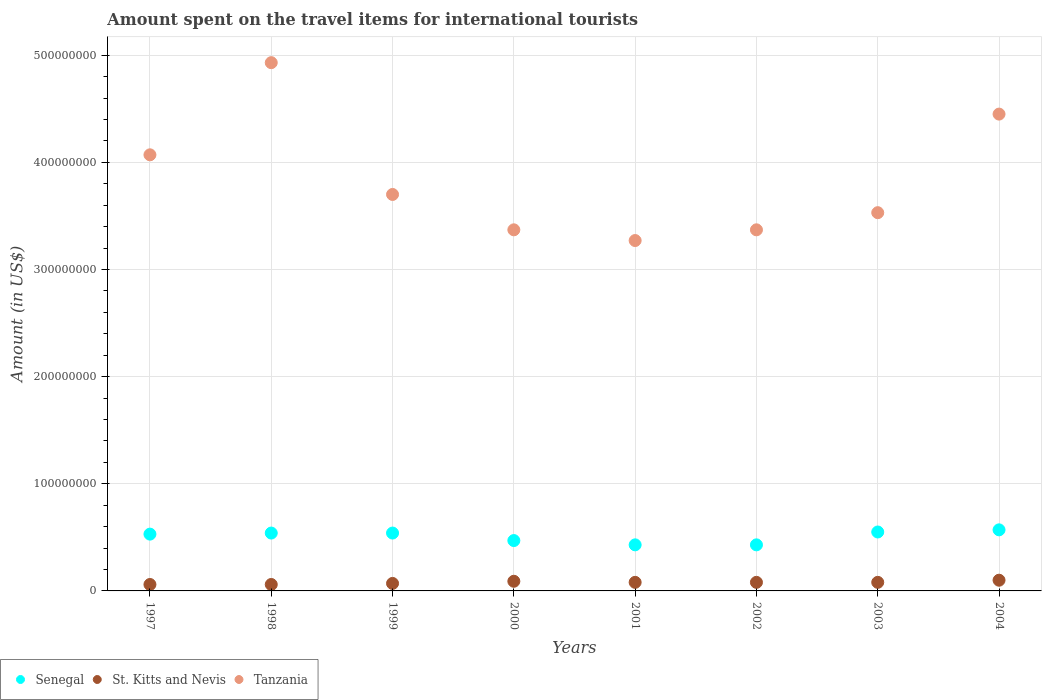How many different coloured dotlines are there?
Provide a succinct answer. 3. Is the number of dotlines equal to the number of legend labels?
Give a very brief answer. Yes. What is the amount spent on the travel items for international tourists in St. Kitts and Nevis in 2000?
Offer a very short reply. 9.00e+06. Across all years, what is the maximum amount spent on the travel items for international tourists in Tanzania?
Ensure brevity in your answer.  4.93e+08. Across all years, what is the minimum amount spent on the travel items for international tourists in Senegal?
Provide a succinct answer. 4.30e+07. What is the total amount spent on the travel items for international tourists in St. Kitts and Nevis in the graph?
Provide a short and direct response. 6.20e+07. What is the difference between the amount spent on the travel items for international tourists in St. Kitts and Nevis in 1997 and that in 2000?
Your answer should be compact. -3.00e+06. What is the difference between the amount spent on the travel items for international tourists in Tanzania in 2004 and the amount spent on the travel items for international tourists in St. Kitts and Nevis in 2003?
Offer a terse response. 4.37e+08. What is the average amount spent on the travel items for international tourists in St. Kitts and Nevis per year?
Your response must be concise. 7.75e+06. In the year 2003, what is the difference between the amount spent on the travel items for international tourists in Senegal and amount spent on the travel items for international tourists in Tanzania?
Provide a succinct answer. -2.98e+08. What is the ratio of the amount spent on the travel items for international tourists in St. Kitts and Nevis in 1997 to that in 2002?
Your answer should be compact. 0.75. Is the amount spent on the travel items for international tourists in St. Kitts and Nevis in 2001 less than that in 2002?
Ensure brevity in your answer.  No. What is the difference between the highest and the second highest amount spent on the travel items for international tourists in Tanzania?
Your answer should be compact. 4.80e+07. What is the difference between the highest and the lowest amount spent on the travel items for international tourists in St. Kitts and Nevis?
Your answer should be very brief. 4.00e+06. Is it the case that in every year, the sum of the amount spent on the travel items for international tourists in St. Kitts and Nevis and amount spent on the travel items for international tourists in Senegal  is greater than the amount spent on the travel items for international tourists in Tanzania?
Your answer should be compact. No. Does the amount spent on the travel items for international tourists in Senegal monotonically increase over the years?
Your answer should be compact. No. Is the amount spent on the travel items for international tourists in Senegal strictly greater than the amount spent on the travel items for international tourists in Tanzania over the years?
Ensure brevity in your answer.  No. Is the amount spent on the travel items for international tourists in Senegal strictly less than the amount spent on the travel items for international tourists in St. Kitts and Nevis over the years?
Provide a succinct answer. No. How many dotlines are there?
Offer a very short reply. 3. How many years are there in the graph?
Offer a terse response. 8. Where does the legend appear in the graph?
Ensure brevity in your answer.  Bottom left. How many legend labels are there?
Offer a terse response. 3. What is the title of the graph?
Make the answer very short. Amount spent on the travel items for international tourists. What is the label or title of the X-axis?
Provide a succinct answer. Years. What is the label or title of the Y-axis?
Make the answer very short. Amount (in US$). What is the Amount (in US$) in Senegal in 1997?
Offer a terse response. 5.30e+07. What is the Amount (in US$) in St. Kitts and Nevis in 1997?
Offer a terse response. 6.00e+06. What is the Amount (in US$) in Tanzania in 1997?
Offer a very short reply. 4.07e+08. What is the Amount (in US$) of Senegal in 1998?
Your answer should be very brief. 5.40e+07. What is the Amount (in US$) of Tanzania in 1998?
Ensure brevity in your answer.  4.93e+08. What is the Amount (in US$) of Senegal in 1999?
Offer a very short reply. 5.40e+07. What is the Amount (in US$) of St. Kitts and Nevis in 1999?
Your answer should be very brief. 7.00e+06. What is the Amount (in US$) of Tanzania in 1999?
Your response must be concise. 3.70e+08. What is the Amount (in US$) in Senegal in 2000?
Your answer should be very brief. 4.70e+07. What is the Amount (in US$) of St. Kitts and Nevis in 2000?
Keep it short and to the point. 9.00e+06. What is the Amount (in US$) in Tanzania in 2000?
Ensure brevity in your answer.  3.37e+08. What is the Amount (in US$) in Senegal in 2001?
Provide a short and direct response. 4.30e+07. What is the Amount (in US$) in St. Kitts and Nevis in 2001?
Ensure brevity in your answer.  8.00e+06. What is the Amount (in US$) of Tanzania in 2001?
Offer a very short reply. 3.27e+08. What is the Amount (in US$) of Senegal in 2002?
Offer a terse response. 4.30e+07. What is the Amount (in US$) in St. Kitts and Nevis in 2002?
Offer a very short reply. 8.00e+06. What is the Amount (in US$) in Tanzania in 2002?
Make the answer very short. 3.37e+08. What is the Amount (in US$) of Senegal in 2003?
Ensure brevity in your answer.  5.50e+07. What is the Amount (in US$) in St. Kitts and Nevis in 2003?
Your answer should be very brief. 8.00e+06. What is the Amount (in US$) in Tanzania in 2003?
Provide a succinct answer. 3.53e+08. What is the Amount (in US$) of Senegal in 2004?
Make the answer very short. 5.70e+07. What is the Amount (in US$) in Tanzania in 2004?
Provide a short and direct response. 4.45e+08. Across all years, what is the maximum Amount (in US$) in Senegal?
Keep it short and to the point. 5.70e+07. Across all years, what is the maximum Amount (in US$) of Tanzania?
Your answer should be compact. 4.93e+08. Across all years, what is the minimum Amount (in US$) of Senegal?
Keep it short and to the point. 4.30e+07. Across all years, what is the minimum Amount (in US$) of Tanzania?
Keep it short and to the point. 3.27e+08. What is the total Amount (in US$) in Senegal in the graph?
Your answer should be compact. 4.06e+08. What is the total Amount (in US$) in St. Kitts and Nevis in the graph?
Provide a succinct answer. 6.20e+07. What is the total Amount (in US$) of Tanzania in the graph?
Ensure brevity in your answer.  3.07e+09. What is the difference between the Amount (in US$) in Senegal in 1997 and that in 1998?
Your answer should be compact. -1.00e+06. What is the difference between the Amount (in US$) in St. Kitts and Nevis in 1997 and that in 1998?
Provide a short and direct response. 0. What is the difference between the Amount (in US$) of Tanzania in 1997 and that in 1998?
Your response must be concise. -8.60e+07. What is the difference between the Amount (in US$) in St. Kitts and Nevis in 1997 and that in 1999?
Ensure brevity in your answer.  -1.00e+06. What is the difference between the Amount (in US$) in Tanzania in 1997 and that in 1999?
Give a very brief answer. 3.70e+07. What is the difference between the Amount (in US$) in Senegal in 1997 and that in 2000?
Provide a succinct answer. 6.00e+06. What is the difference between the Amount (in US$) in Tanzania in 1997 and that in 2000?
Your response must be concise. 7.00e+07. What is the difference between the Amount (in US$) of Tanzania in 1997 and that in 2001?
Offer a very short reply. 8.00e+07. What is the difference between the Amount (in US$) in Tanzania in 1997 and that in 2002?
Offer a terse response. 7.00e+07. What is the difference between the Amount (in US$) of Senegal in 1997 and that in 2003?
Give a very brief answer. -2.00e+06. What is the difference between the Amount (in US$) of Tanzania in 1997 and that in 2003?
Your answer should be compact. 5.40e+07. What is the difference between the Amount (in US$) in St. Kitts and Nevis in 1997 and that in 2004?
Provide a short and direct response. -4.00e+06. What is the difference between the Amount (in US$) in Tanzania in 1997 and that in 2004?
Provide a succinct answer. -3.80e+07. What is the difference between the Amount (in US$) in Senegal in 1998 and that in 1999?
Keep it short and to the point. 0. What is the difference between the Amount (in US$) in Tanzania in 1998 and that in 1999?
Give a very brief answer. 1.23e+08. What is the difference between the Amount (in US$) in St. Kitts and Nevis in 1998 and that in 2000?
Your response must be concise. -3.00e+06. What is the difference between the Amount (in US$) in Tanzania in 1998 and that in 2000?
Your answer should be compact. 1.56e+08. What is the difference between the Amount (in US$) in Senegal in 1998 and that in 2001?
Provide a short and direct response. 1.10e+07. What is the difference between the Amount (in US$) in Tanzania in 1998 and that in 2001?
Keep it short and to the point. 1.66e+08. What is the difference between the Amount (in US$) in Senegal in 1998 and that in 2002?
Your answer should be compact. 1.10e+07. What is the difference between the Amount (in US$) of Tanzania in 1998 and that in 2002?
Your answer should be compact. 1.56e+08. What is the difference between the Amount (in US$) of Senegal in 1998 and that in 2003?
Make the answer very short. -1.00e+06. What is the difference between the Amount (in US$) of St. Kitts and Nevis in 1998 and that in 2003?
Your response must be concise. -2.00e+06. What is the difference between the Amount (in US$) in Tanzania in 1998 and that in 2003?
Your answer should be very brief. 1.40e+08. What is the difference between the Amount (in US$) in Senegal in 1998 and that in 2004?
Ensure brevity in your answer.  -3.00e+06. What is the difference between the Amount (in US$) in Tanzania in 1998 and that in 2004?
Offer a terse response. 4.80e+07. What is the difference between the Amount (in US$) in Senegal in 1999 and that in 2000?
Your response must be concise. 7.00e+06. What is the difference between the Amount (in US$) of St. Kitts and Nevis in 1999 and that in 2000?
Keep it short and to the point. -2.00e+06. What is the difference between the Amount (in US$) of Tanzania in 1999 and that in 2000?
Ensure brevity in your answer.  3.30e+07. What is the difference between the Amount (in US$) in Senegal in 1999 and that in 2001?
Ensure brevity in your answer.  1.10e+07. What is the difference between the Amount (in US$) in Tanzania in 1999 and that in 2001?
Keep it short and to the point. 4.30e+07. What is the difference between the Amount (in US$) of Senegal in 1999 and that in 2002?
Your response must be concise. 1.10e+07. What is the difference between the Amount (in US$) in Tanzania in 1999 and that in 2002?
Make the answer very short. 3.30e+07. What is the difference between the Amount (in US$) in St. Kitts and Nevis in 1999 and that in 2003?
Provide a short and direct response. -1.00e+06. What is the difference between the Amount (in US$) of Tanzania in 1999 and that in 2003?
Your answer should be very brief. 1.70e+07. What is the difference between the Amount (in US$) in Senegal in 1999 and that in 2004?
Your response must be concise. -3.00e+06. What is the difference between the Amount (in US$) in St. Kitts and Nevis in 1999 and that in 2004?
Make the answer very short. -3.00e+06. What is the difference between the Amount (in US$) in Tanzania in 1999 and that in 2004?
Offer a very short reply. -7.50e+07. What is the difference between the Amount (in US$) of Senegal in 2000 and that in 2001?
Keep it short and to the point. 4.00e+06. What is the difference between the Amount (in US$) of Tanzania in 2000 and that in 2001?
Keep it short and to the point. 1.00e+07. What is the difference between the Amount (in US$) of Senegal in 2000 and that in 2003?
Offer a terse response. -8.00e+06. What is the difference between the Amount (in US$) in Tanzania in 2000 and that in 2003?
Keep it short and to the point. -1.60e+07. What is the difference between the Amount (in US$) of Senegal in 2000 and that in 2004?
Offer a terse response. -1.00e+07. What is the difference between the Amount (in US$) of Tanzania in 2000 and that in 2004?
Your response must be concise. -1.08e+08. What is the difference between the Amount (in US$) of Senegal in 2001 and that in 2002?
Keep it short and to the point. 0. What is the difference between the Amount (in US$) of Tanzania in 2001 and that in 2002?
Provide a succinct answer. -1.00e+07. What is the difference between the Amount (in US$) in Senegal in 2001 and that in 2003?
Offer a very short reply. -1.20e+07. What is the difference between the Amount (in US$) of Tanzania in 2001 and that in 2003?
Offer a terse response. -2.60e+07. What is the difference between the Amount (in US$) of Senegal in 2001 and that in 2004?
Offer a terse response. -1.40e+07. What is the difference between the Amount (in US$) of St. Kitts and Nevis in 2001 and that in 2004?
Offer a terse response. -2.00e+06. What is the difference between the Amount (in US$) in Tanzania in 2001 and that in 2004?
Your response must be concise. -1.18e+08. What is the difference between the Amount (in US$) of Senegal in 2002 and that in 2003?
Offer a terse response. -1.20e+07. What is the difference between the Amount (in US$) in Tanzania in 2002 and that in 2003?
Offer a terse response. -1.60e+07. What is the difference between the Amount (in US$) in Senegal in 2002 and that in 2004?
Your answer should be very brief. -1.40e+07. What is the difference between the Amount (in US$) of St. Kitts and Nevis in 2002 and that in 2004?
Provide a succinct answer. -2.00e+06. What is the difference between the Amount (in US$) in Tanzania in 2002 and that in 2004?
Ensure brevity in your answer.  -1.08e+08. What is the difference between the Amount (in US$) in Senegal in 2003 and that in 2004?
Your answer should be very brief. -2.00e+06. What is the difference between the Amount (in US$) in Tanzania in 2003 and that in 2004?
Your answer should be compact. -9.20e+07. What is the difference between the Amount (in US$) in Senegal in 1997 and the Amount (in US$) in St. Kitts and Nevis in 1998?
Provide a succinct answer. 4.70e+07. What is the difference between the Amount (in US$) of Senegal in 1997 and the Amount (in US$) of Tanzania in 1998?
Give a very brief answer. -4.40e+08. What is the difference between the Amount (in US$) in St. Kitts and Nevis in 1997 and the Amount (in US$) in Tanzania in 1998?
Provide a succinct answer. -4.87e+08. What is the difference between the Amount (in US$) of Senegal in 1997 and the Amount (in US$) of St. Kitts and Nevis in 1999?
Your response must be concise. 4.60e+07. What is the difference between the Amount (in US$) in Senegal in 1997 and the Amount (in US$) in Tanzania in 1999?
Make the answer very short. -3.17e+08. What is the difference between the Amount (in US$) in St. Kitts and Nevis in 1997 and the Amount (in US$) in Tanzania in 1999?
Your response must be concise. -3.64e+08. What is the difference between the Amount (in US$) of Senegal in 1997 and the Amount (in US$) of St. Kitts and Nevis in 2000?
Ensure brevity in your answer.  4.40e+07. What is the difference between the Amount (in US$) of Senegal in 1997 and the Amount (in US$) of Tanzania in 2000?
Your answer should be very brief. -2.84e+08. What is the difference between the Amount (in US$) in St. Kitts and Nevis in 1997 and the Amount (in US$) in Tanzania in 2000?
Give a very brief answer. -3.31e+08. What is the difference between the Amount (in US$) in Senegal in 1997 and the Amount (in US$) in St. Kitts and Nevis in 2001?
Give a very brief answer. 4.50e+07. What is the difference between the Amount (in US$) in Senegal in 1997 and the Amount (in US$) in Tanzania in 2001?
Ensure brevity in your answer.  -2.74e+08. What is the difference between the Amount (in US$) in St. Kitts and Nevis in 1997 and the Amount (in US$) in Tanzania in 2001?
Ensure brevity in your answer.  -3.21e+08. What is the difference between the Amount (in US$) in Senegal in 1997 and the Amount (in US$) in St. Kitts and Nevis in 2002?
Make the answer very short. 4.50e+07. What is the difference between the Amount (in US$) of Senegal in 1997 and the Amount (in US$) of Tanzania in 2002?
Give a very brief answer. -2.84e+08. What is the difference between the Amount (in US$) in St. Kitts and Nevis in 1997 and the Amount (in US$) in Tanzania in 2002?
Your answer should be compact. -3.31e+08. What is the difference between the Amount (in US$) of Senegal in 1997 and the Amount (in US$) of St. Kitts and Nevis in 2003?
Your answer should be very brief. 4.50e+07. What is the difference between the Amount (in US$) of Senegal in 1997 and the Amount (in US$) of Tanzania in 2003?
Your answer should be compact. -3.00e+08. What is the difference between the Amount (in US$) of St. Kitts and Nevis in 1997 and the Amount (in US$) of Tanzania in 2003?
Offer a terse response. -3.47e+08. What is the difference between the Amount (in US$) in Senegal in 1997 and the Amount (in US$) in St. Kitts and Nevis in 2004?
Provide a succinct answer. 4.30e+07. What is the difference between the Amount (in US$) in Senegal in 1997 and the Amount (in US$) in Tanzania in 2004?
Keep it short and to the point. -3.92e+08. What is the difference between the Amount (in US$) in St. Kitts and Nevis in 1997 and the Amount (in US$) in Tanzania in 2004?
Give a very brief answer. -4.39e+08. What is the difference between the Amount (in US$) in Senegal in 1998 and the Amount (in US$) in St. Kitts and Nevis in 1999?
Give a very brief answer. 4.70e+07. What is the difference between the Amount (in US$) in Senegal in 1998 and the Amount (in US$) in Tanzania in 1999?
Your answer should be compact. -3.16e+08. What is the difference between the Amount (in US$) of St. Kitts and Nevis in 1998 and the Amount (in US$) of Tanzania in 1999?
Provide a short and direct response. -3.64e+08. What is the difference between the Amount (in US$) of Senegal in 1998 and the Amount (in US$) of St. Kitts and Nevis in 2000?
Provide a short and direct response. 4.50e+07. What is the difference between the Amount (in US$) in Senegal in 1998 and the Amount (in US$) in Tanzania in 2000?
Offer a terse response. -2.83e+08. What is the difference between the Amount (in US$) in St. Kitts and Nevis in 1998 and the Amount (in US$) in Tanzania in 2000?
Provide a short and direct response. -3.31e+08. What is the difference between the Amount (in US$) of Senegal in 1998 and the Amount (in US$) of St. Kitts and Nevis in 2001?
Offer a terse response. 4.60e+07. What is the difference between the Amount (in US$) in Senegal in 1998 and the Amount (in US$) in Tanzania in 2001?
Make the answer very short. -2.73e+08. What is the difference between the Amount (in US$) of St. Kitts and Nevis in 1998 and the Amount (in US$) of Tanzania in 2001?
Offer a very short reply. -3.21e+08. What is the difference between the Amount (in US$) of Senegal in 1998 and the Amount (in US$) of St. Kitts and Nevis in 2002?
Make the answer very short. 4.60e+07. What is the difference between the Amount (in US$) of Senegal in 1998 and the Amount (in US$) of Tanzania in 2002?
Offer a terse response. -2.83e+08. What is the difference between the Amount (in US$) in St. Kitts and Nevis in 1998 and the Amount (in US$) in Tanzania in 2002?
Your response must be concise. -3.31e+08. What is the difference between the Amount (in US$) of Senegal in 1998 and the Amount (in US$) of St. Kitts and Nevis in 2003?
Provide a short and direct response. 4.60e+07. What is the difference between the Amount (in US$) in Senegal in 1998 and the Amount (in US$) in Tanzania in 2003?
Provide a succinct answer. -2.99e+08. What is the difference between the Amount (in US$) of St. Kitts and Nevis in 1998 and the Amount (in US$) of Tanzania in 2003?
Offer a very short reply. -3.47e+08. What is the difference between the Amount (in US$) in Senegal in 1998 and the Amount (in US$) in St. Kitts and Nevis in 2004?
Offer a very short reply. 4.40e+07. What is the difference between the Amount (in US$) in Senegal in 1998 and the Amount (in US$) in Tanzania in 2004?
Your answer should be very brief. -3.91e+08. What is the difference between the Amount (in US$) of St. Kitts and Nevis in 1998 and the Amount (in US$) of Tanzania in 2004?
Provide a succinct answer. -4.39e+08. What is the difference between the Amount (in US$) in Senegal in 1999 and the Amount (in US$) in St. Kitts and Nevis in 2000?
Make the answer very short. 4.50e+07. What is the difference between the Amount (in US$) in Senegal in 1999 and the Amount (in US$) in Tanzania in 2000?
Your answer should be very brief. -2.83e+08. What is the difference between the Amount (in US$) in St. Kitts and Nevis in 1999 and the Amount (in US$) in Tanzania in 2000?
Offer a terse response. -3.30e+08. What is the difference between the Amount (in US$) in Senegal in 1999 and the Amount (in US$) in St. Kitts and Nevis in 2001?
Keep it short and to the point. 4.60e+07. What is the difference between the Amount (in US$) in Senegal in 1999 and the Amount (in US$) in Tanzania in 2001?
Make the answer very short. -2.73e+08. What is the difference between the Amount (in US$) of St. Kitts and Nevis in 1999 and the Amount (in US$) of Tanzania in 2001?
Provide a succinct answer. -3.20e+08. What is the difference between the Amount (in US$) in Senegal in 1999 and the Amount (in US$) in St. Kitts and Nevis in 2002?
Give a very brief answer. 4.60e+07. What is the difference between the Amount (in US$) in Senegal in 1999 and the Amount (in US$) in Tanzania in 2002?
Your response must be concise. -2.83e+08. What is the difference between the Amount (in US$) in St. Kitts and Nevis in 1999 and the Amount (in US$) in Tanzania in 2002?
Provide a short and direct response. -3.30e+08. What is the difference between the Amount (in US$) of Senegal in 1999 and the Amount (in US$) of St. Kitts and Nevis in 2003?
Keep it short and to the point. 4.60e+07. What is the difference between the Amount (in US$) of Senegal in 1999 and the Amount (in US$) of Tanzania in 2003?
Offer a terse response. -2.99e+08. What is the difference between the Amount (in US$) in St. Kitts and Nevis in 1999 and the Amount (in US$) in Tanzania in 2003?
Your answer should be compact. -3.46e+08. What is the difference between the Amount (in US$) in Senegal in 1999 and the Amount (in US$) in St. Kitts and Nevis in 2004?
Your answer should be compact. 4.40e+07. What is the difference between the Amount (in US$) of Senegal in 1999 and the Amount (in US$) of Tanzania in 2004?
Your answer should be very brief. -3.91e+08. What is the difference between the Amount (in US$) of St. Kitts and Nevis in 1999 and the Amount (in US$) of Tanzania in 2004?
Provide a succinct answer. -4.38e+08. What is the difference between the Amount (in US$) in Senegal in 2000 and the Amount (in US$) in St. Kitts and Nevis in 2001?
Offer a very short reply. 3.90e+07. What is the difference between the Amount (in US$) in Senegal in 2000 and the Amount (in US$) in Tanzania in 2001?
Make the answer very short. -2.80e+08. What is the difference between the Amount (in US$) of St. Kitts and Nevis in 2000 and the Amount (in US$) of Tanzania in 2001?
Your response must be concise. -3.18e+08. What is the difference between the Amount (in US$) in Senegal in 2000 and the Amount (in US$) in St. Kitts and Nevis in 2002?
Make the answer very short. 3.90e+07. What is the difference between the Amount (in US$) in Senegal in 2000 and the Amount (in US$) in Tanzania in 2002?
Ensure brevity in your answer.  -2.90e+08. What is the difference between the Amount (in US$) of St. Kitts and Nevis in 2000 and the Amount (in US$) of Tanzania in 2002?
Your response must be concise. -3.28e+08. What is the difference between the Amount (in US$) in Senegal in 2000 and the Amount (in US$) in St. Kitts and Nevis in 2003?
Offer a very short reply. 3.90e+07. What is the difference between the Amount (in US$) in Senegal in 2000 and the Amount (in US$) in Tanzania in 2003?
Make the answer very short. -3.06e+08. What is the difference between the Amount (in US$) of St. Kitts and Nevis in 2000 and the Amount (in US$) of Tanzania in 2003?
Offer a terse response. -3.44e+08. What is the difference between the Amount (in US$) in Senegal in 2000 and the Amount (in US$) in St. Kitts and Nevis in 2004?
Keep it short and to the point. 3.70e+07. What is the difference between the Amount (in US$) in Senegal in 2000 and the Amount (in US$) in Tanzania in 2004?
Your response must be concise. -3.98e+08. What is the difference between the Amount (in US$) of St. Kitts and Nevis in 2000 and the Amount (in US$) of Tanzania in 2004?
Make the answer very short. -4.36e+08. What is the difference between the Amount (in US$) in Senegal in 2001 and the Amount (in US$) in St. Kitts and Nevis in 2002?
Give a very brief answer. 3.50e+07. What is the difference between the Amount (in US$) of Senegal in 2001 and the Amount (in US$) of Tanzania in 2002?
Provide a short and direct response. -2.94e+08. What is the difference between the Amount (in US$) in St. Kitts and Nevis in 2001 and the Amount (in US$) in Tanzania in 2002?
Your answer should be very brief. -3.29e+08. What is the difference between the Amount (in US$) in Senegal in 2001 and the Amount (in US$) in St. Kitts and Nevis in 2003?
Provide a short and direct response. 3.50e+07. What is the difference between the Amount (in US$) in Senegal in 2001 and the Amount (in US$) in Tanzania in 2003?
Keep it short and to the point. -3.10e+08. What is the difference between the Amount (in US$) in St. Kitts and Nevis in 2001 and the Amount (in US$) in Tanzania in 2003?
Provide a succinct answer. -3.45e+08. What is the difference between the Amount (in US$) in Senegal in 2001 and the Amount (in US$) in St. Kitts and Nevis in 2004?
Ensure brevity in your answer.  3.30e+07. What is the difference between the Amount (in US$) in Senegal in 2001 and the Amount (in US$) in Tanzania in 2004?
Make the answer very short. -4.02e+08. What is the difference between the Amount (in US$) of St. Kitts and Nevis in 2001 and the Amount (in US$) of Tanzania in 2004?
Your answer should be compact. -4.37e+08. What is the difference between the Amount (in US$) in Senegal in 2002 and the Amount (in US$) in St. Kitts and Nevis in 2003?
Your answer should be very brief. 3.50e+07. What is the difference between the Amount (in US$) in Senegal in 2002 and the Amount (in US$) in Tanzania in 2003?
Provide a succinct answer. -3.10e+08. What is the difference between the Amount (in US$) of St. Kitts and Nevis in 2002 and the Amount (in US$) of Tanzania in 2003?
Your response must be concise. -3.45e+08. What is the difference between the Amount (in US$) of Senegal in 2002 and the Amount (in US$) of St. Kitts and Nevis in 2004?
Provide a short and direct response. 3.30e+07. What is the difference between the Amount (in US$) of Senegal in 2002 and the Amount (in US$) of Tanzania in 2004?
Ensure brevity in your answer.  -4.02e+08. What is the difference between the Amount (in US$) in St. Kitts and Nevis in 2002 and the Amount (in US$) in Tanzania in 2004?
Your answer should be compact. -4.37e+08. What is the difference between the Amount (in US$) in Senegal in 2003 and the Amount (in US$) in St. Kitts and Nevis in 2004?
Provide a short and direct response. 4.50e+07. What is the difference between the Amount (in US$) in Senegal in 2003 and the Amount (in US$) in Tanzania in 2004?
Keep it short and to the point. -3.90e+08. What is the difference between the Amount (in US$) in St. Kitts and Nevis in 2003 and the Amount (in US$) in Tanzania in 2004?
Offer a terse response. -4.37e+08. What is the average Amount (in US$) of Senegal per year?
Your answer should be very brief. 5.08e+07. What is the average Amount (in US$) of St. Kitts and Nevis per year?
Provide a short and direct response. 7.75e+06. What is the average Amount (in US$) of Tanzania per year?
Provide a short and direct response. 3.84e+08. In the year 1997, what is the difference between the Amount (in US$) in Senegal and Amount (in US$) in St. Kitts and Nevis?
Provide a succinct answer. 4.70e+07. In the year 1997, what is the difference between the Amount (in US$) in Senegal and Amount (in US$) in Tanzania?
Offer a very short reply. -3.54e+08. In the year 1997, what is the difference between the Amount (in US$) of St. Kitts and Nevis and Amount (in US$) of Tanzania?
Provide a short and direct response. -4.01e+08. In the year 1998, what is the difference between the Amount (in US$) of Senegal and Amount (in US$) of St. Kitts and Nevis?
Keep it short and to the point. 4.80e+07. In the year 1998, what is the difference between the Amount (in US$) in Senegal and Amount (in US$) in Tanzania?
Your answer should be very brief. -4.39e+08. In the year 1998, what is the difference between the Amount (in US$) of St. Kitts and Nevis and Amount (in US$) of Tanzania?
Make the answer very short. -4.87e+08. In the year 1999, what is the difference between the Amount (in US$) of Senegal and Amount (in US$) of St. Kitts and Nevis?
Provide a succinct answer. 4.70e+07. In the year 1999, what is the difference between the Amount (in US$) of Senegal and Amount (in US$) of Tanzania?
Provide a short and direct response. -3.16e+08. In the year 1999, what is the difference between the Amount (in US$) of St. Kitts and Nevis and Amount (in US$) of Tanzania?
Keep it short and to the point. -3.63e+08. In the year 2000, what is the difference between the Amount (in US$) of Senegal and Amount (in US$) of St. Kitts and Nevis?
Provide a short and direct response. 3.80e+07. In the year 2000, what is the difference between the Amount (in US$) in Senegal and Amount (in US$) in Tanzania?
Your response must be concise. -2.90e+08. In the year 2000, what is the difference between the Amount (in US$) in St. Kitts and Nevis and Amount (in US$) in Tanzania?
Provide a succinct answer. -3.28e+08. In the year 2001, what is the difference between the Amount (in US$) of Senegal and Amount (in US$) of St. Kitts and Nevis?
Make the answer very short. 3.50e+07. In the year 2001, what is the difference between the Amount (in US$) of Senegal and Amount (in US$) of Tanzania?
Make the answer very short. -2.84e+08. In the year 2001, what is the difference between the Amount (in US$) in St. Kitts and Nevis and Amount (in US$) in Tanzania?
Provide a succinct answer. -3.19e+08. In the year 2002, what is the difference between the Amount (in US$) in Senegal and Amount (in US$) in St. Kitts and Nevis?
Your answer should be compact. 3.50e+07. In the year 2002, what is the difference between the Amount (in US$) in Senegal and Amount (in US$) in Tanzania?
Make the answer very short. -2.94e+08. In the year 2002, what is the difference between the Amount (in US$) in St. Kitts and Nevis and Amount (in US$) in Tanzania?
Offer a terse response. -3.29e+08. In the year 2003, what is the difference between the Amount (in US$) in Senegal and Amount (in US$) in St. Kitts and Nevis?
Give a very brief answer. 4.70e+07. In the year 2003, what is the difference between the Amount (in US$) of Senegal and Amount (in US$) of Tanzania?
Offer a very short reply. -2.98e+08. In the year 2003, what is the difference between the Amount (in US$) of St. Kitts and Nevis and Amount (in US$) of Tanzania?
Ensure brevity in your answer.  -3.45e+08. In the year 2004, what is the difference between the Amount (in US$) in Senegal and Amount (in US$) in St. Kitts and Nevis?
Your response must be concise. 4.70e+07. In the year 2004, what is the difference between the Amount (in US$) of Senegal and Amount (in US$) of Tanzania?
Provide a short and direct response. -3.88e+08. In the year 2004, what is the difference between the Amount (in US$) in St. Kitts and Nevis and Amount (in US$) in Tanzania?
Offer a terse response. -4.35e+08. What is the ratio of the Amount (in US$) in Senegal in 1997 to that in 1998?
Give a very brief answer. 0.98. What is the ratio of the Amount (in US$) of St. Kitts and Nevis in 1997 to that in 1998?
Provide a succinct answer. 1. What is the ratio of the Amount (in US$) of Tanzania in 1997 to that in 1998?
Offer a terse response. 0.83. What is the ratio of the Amount (in US$) of Senegal in 1997 to that in 1999?
Provide a succinct answer. 0.98. What is the ratio of the Amount (in US$) of Tanzania in 1997 to that in 1999?
Give a very brief answer. 1.1. What is the ratio of the Amount (in US$) in Senegal in 1997 to that in 2000?
Keep it short and to the point. 1.13. What is the ratio of the Amount (in US$) in St. Kitts and Nevis in 1997 to that in 2000?
Make the answer very short. 0.67. What is the ratio of the Amount (in US$) of Tanzania in 1997 to that in 2000?
Ensure brevity in your answer.  1.21. What is the ratio of the Amount (in US$) of Senegal in 1997 to that in 2001?
Your answer should be very brief. 1.23. What is the ratio of the Amount (in US$) in St. Kitts and Nevis in 1997 to that in 2001?
Provide a succinct answer. 0.75. What is the ratio of the Amount (in US$) of Tanzania in 1997 to that in 2001?
Ensure brevity in your answer.  1.24. What is the ratio of the Amount (in US$) in Senegal in 1997 to that in 2002?
Make the answer very short. 1.23. What is the ratio of the Amount (in US$) in Tanzania in 1997 to that in 2002?
Your response must be concise. 1.21. What is the ratio of the Amount (in US$) in Senegal in 1997 to that in 2003?
Provide a succinct answer. 0.96. What is the ratio of the Amount (in US$) of St. Kitts and Nevis in 1997 to that in 2003?
Your response must be concise. 0.75. What is the ratio of the Amount (in US$) in Tanzania in 1997 to that in 2003?
Your answer should be compact. 1.15. What is the ratio of the Amount (in US$) of Senegal in 1997 to that in 2004?
Offer a terse response. 0.93. What is the ratio of the Amount (in US$) in Tanzania in 1997 to that in 2004?
Offer a very short reply. 0.91. What is the ratio of the Amount (in US$) in Senegal in 1998 to that in 1999?
Make the answer very short. 1. What is the ratio of the Amount (in US$) in Tanzania in 1998 to that in 1999?
Your answer should be very brief. 1.33. What is the ratio of the Amount (in US$) of Senegal in 1998 to that in 2000?
Offer a very short reply. 1.15. What is the ratio of the Amount (in US$) in St. Kitts and Nevis in 1998 to that in 2000?
Your answer should be compact. 0.67. What is the ratio of the Amount (in US$) of Tanzania in 1998 to that in 2000?
Your answer should be compact. 1.46. What is the ratio of the Amount (in US$) in Senegal in 1998 to that in 2001?
Provide a succinct answer. 1.26. What is the ratio of the Amount (in US$) in Tanzania in 1998 to that in 2001?
Your answer should be compact. 1.51. What is the ratio of the Amount (in US$) in Senegal in 1998 to that in 2002?
Offer a very short reply. 1.26. What is the ratio of the Amount (in US$) in Tanzania in 1998 to that in 2002?
Ensure brevity in your answer.  1.46. What is the ratio of the Amount (in US$) of Senegal in 1998 to that in 2003?
Provide a succinct answer. 0.98. What is the ratio of the Amount (in US$) in Tanzania in 1998 to that in 2003?
Make the answer very short. 1.4. What is the ratio of the Amount (in US$) in Senegal in 1998 to that in 2004?
Your answer should be very brief. 0.95. What is the ratio of the Amount (in US$) of Tanzania in 1998 to that in 2004?
Keep it short and to the point. 1.11. What is the ratio of the Amount (in US$) of Senegal in 1999 to that in 2000?
Give a very brief answer. 1.15. What is the ratio of the Amount (in US$) in St. Kitts and Nevis in 1999 to that in 2000?
Make the answer very short. 0.78. What is the ratio of the Amount (in US$) in Tanzania in 1999 to that in 2000?
Ensure brevity in your answer.  1.1. What is the ratio of the Amount (in US$) of Senegal in 1999 to that in 2001?
Your response must be concise. 1.26. What is the ratio of the Amount (in US$) in St. Kitts and Nevis in 1999 to that in 2001?
Your response must be concise. 0.88. What is the ratio of the Amount (in US$) of Tanzania in 1999 to that in 2001?
Your answer should be very brief. 1.13. What is the ratio of the Amount (in US$) of Senegal in 1999 to that in 2002?
Your response must be concise. 1.26. What is the ratio of the Amount (in US$) of Tanzania in 1999 to that in 2002?
Keep it short and to the point. 1.1. What is the ratio of the Amount (in US$) of Senegal in 1999 to that in 2003?
Ensure brevity in your answer.  0.98. What is the ratio of the Amount (in US$) in Tanzania in 1999 to that in 2003?
Provide a succinct answer. 1.05. What is the ratio of the Amount (in US$) in Senegal in 1999 to that in 2004?
Make the answer very short. 0.95. What is the ratio of the Amount (in US$) in Tanzania in 1999 to that in 2004?
Make the answer very short. 0.83. What is the ratio of the Amount (in US$) in Senegal in 2000 to that in 2001?
Your answer should be compact. 1.09. What is the ratio of the Amount (in US$) in Tanzania in 2000 to that in 2001?
Your answer should be compact. 1.03. What is the ratio of the Amount (in US$) of Senegal in 2000 to that in 2002?
Keep it short and to the point. 1.09. What is the ratio of the Amount (in US$) of St. Kitts and Nevis in 2000 to that in 2002?
Provide a succinct answer. 1.12. What is the ratio of the Amount (in US$) of Tanzania in 2000 to that in 2002?
Keep it short and to the point. 1. What is the ratio of the Amount (in US$) in Senegal in 2000 to that in 2003?
Ensure brevity in your answer.  0.85. What is the ratio of the Amount (in US$) of St. Kitts and Nevis in 2000 to that in 2003?
Your answer should be compact. 1.12. What is the ratio of the Amount (in US$) of Tanzania in 2000 to that in 2003?
Ensure brevity in your answer.  0.95. What is the ratio of the Amount (in US$) of Senegal in 2000 to that in 2004?
Your answer should be very brief. 0.82. What is the ratio of the Amount (in US$) of St. Kitts and Nevis in 2000 to that in 2004?
Make the answer very short. 0.9. What is the ratio of the Amount (in US$) of Tanzania in 2000 to that in 2004?
Offer a very short reply. 0.76. What is the ratio of the Amount (in US$) of Tanzania in 2001 to that in 2002?
Your answer should be compact. 0.97. What is the ratio of the Amount (in US$) of Senegal in 2001 to that in 2003?
Keep it short and to the point. 0.78. What is the ratio of the Amount (in US$) in Tanzania in 2001 to that in 2003?
Your answer should be very brief. 0.93. What is the ratio of the Amount (in US$) of Senegal in 2001 to that in 2004?
Ensure brevity in your answer.  0.75. What is the ratio of the Amount (in US$) in St. Kitts and Nevis in 2001 to that in 2004?
Ensure brevity in your answer.  0.8. What is the ratio of the Amount (in US$) of Tanzania in 2001 to that in 2004?
Your answer should be very brief. 0.73. What is the ratio of the Amount (in US$) in Senegal in 2002 to that in 2003?
Provide a short and direct response. 0.78. What is the ratio of the Amount (in US$) in St. Kitts and Nevis in 2002 to that in 2003?
Your answer should be compact. 1. What is the ratio of the Amount (in US$) in Tanzania in 2002 to that in 2003?
Your answer should be compact. 0.95. What is the ratio of the Amount (in US$) in Senegal in 2002 to that in 2004?
Offer a terse response. 0.75. What is the ratio of the Amount (in US$) of St. Kitts and Nevis in 2002 to that in 2004?
Make the answer very short. 0.8. What is the ratio of the Amount (in US$) in Tanzania in 2002 to that in 2004?
Offer a terse response. 0.76. What is the ratio of the Amount (in US$) of Senegal in 2003 to that in 2004?
Provide a short and direct response. 0.96. What is the ratio of the Amount (in US$) of St. Kitts and Nevis in 2003 to that in 2004?
Your response must be concise. 0.8. What is the ratio of the Amount (in US$) of Tanzania in 2003 to that in 2004?
Keep it short and to the point. 0.79. What is the difference between the highest and the second highest Amount (in US$) in Tanzania?
Ensure brevity in your answer.  4.80e+07. What is the difference between the highest and the lowest Amount (in US$) in Senegal?
Your answer should be very brief. 1.40e+07. What is the difference between the highest and the lowest Amount (in US$) in Tanzania?
Your answer should be very brief. 1.66e+08. 